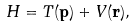Convert formula to latex. <formula><loc_0><loc_0><loc_500><loc_500>H = T ( \mathbf p ) + V ( \mathbf r ) ,</formula> 